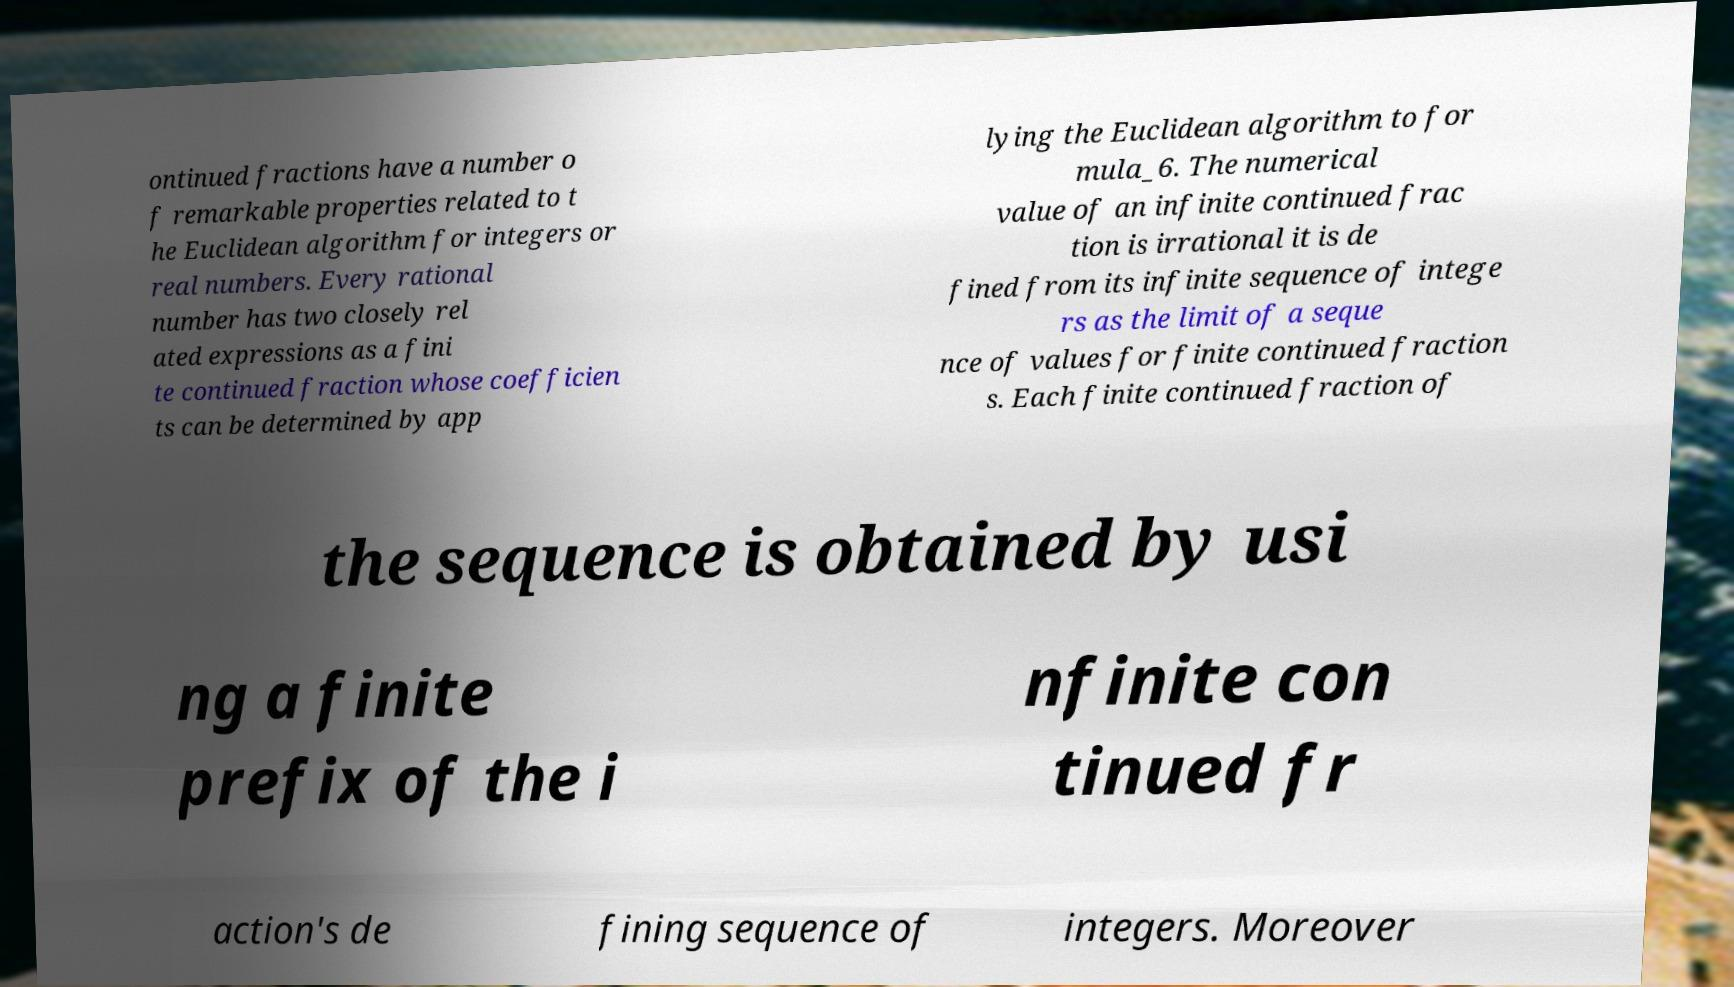I need the written content from this picture converted into text. Can you do that? ontinued fractions have a number o f remarkable properties related to t he Euclidean algorithm for integers or real numbers. Every rational number has two closely rel ated expressions as a fini te continued fraction whose coefficien ts can be determined by app lying the Euclidean algorithm to for mula_6. The numerical value of an infinite continued frac tion is irrational it is de fined from its infinite sequence of intege rs as the limit of a seque nce of values for finite continued fraction s. Each finite continued fraction of the sequence is obtained by usi ng a finite prefix of the i nfinite con tinued fr action's de fining sequence of integers. Moreover 